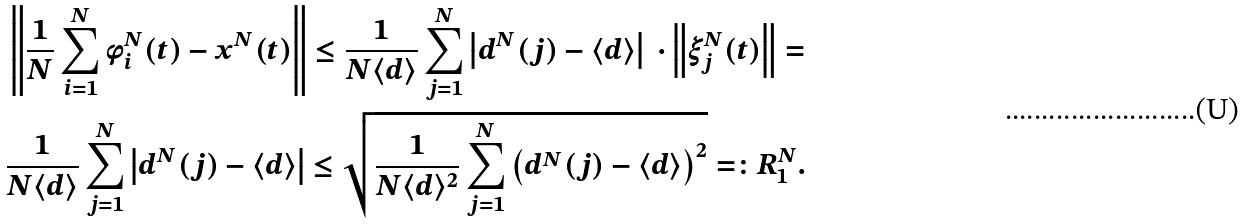Convert formula to latex. <formula><loc_0><loc_0><loc_500><loc_500>& \left \| \frac { 1 } { N } \sum _ { i = 1 } ^ { N } \phi _ { i } ^ { N } ( t ) - x ^ { N } ( t ) \right \| \leq \frac { 1 } { N \langle d \rangle } \sum _ { j = 1 } ^ { N } \left | d ^ { N } ( j ) - \langle d \rangle \right | \ \cdot \left \| \xi _ { j } ^ { N } ( t ) \right \| = \\ & \frac { 1 } { N \langle d \rangle } \sum _ { j = 1 } ^ { N } \left | d ^ { N } ( j ) - \langle d \rangle \right | \leq \sqrt { \frac { 1 } { N \langle d \rangle ^ { 2 } } \sum _ { j = 1 } ^ { N } \left ( d ^ { N } ( j ) - \langle d \rangle \right ) ^ { 2 } } = \colon R _ { 1 } ^ { N } .</formula> 